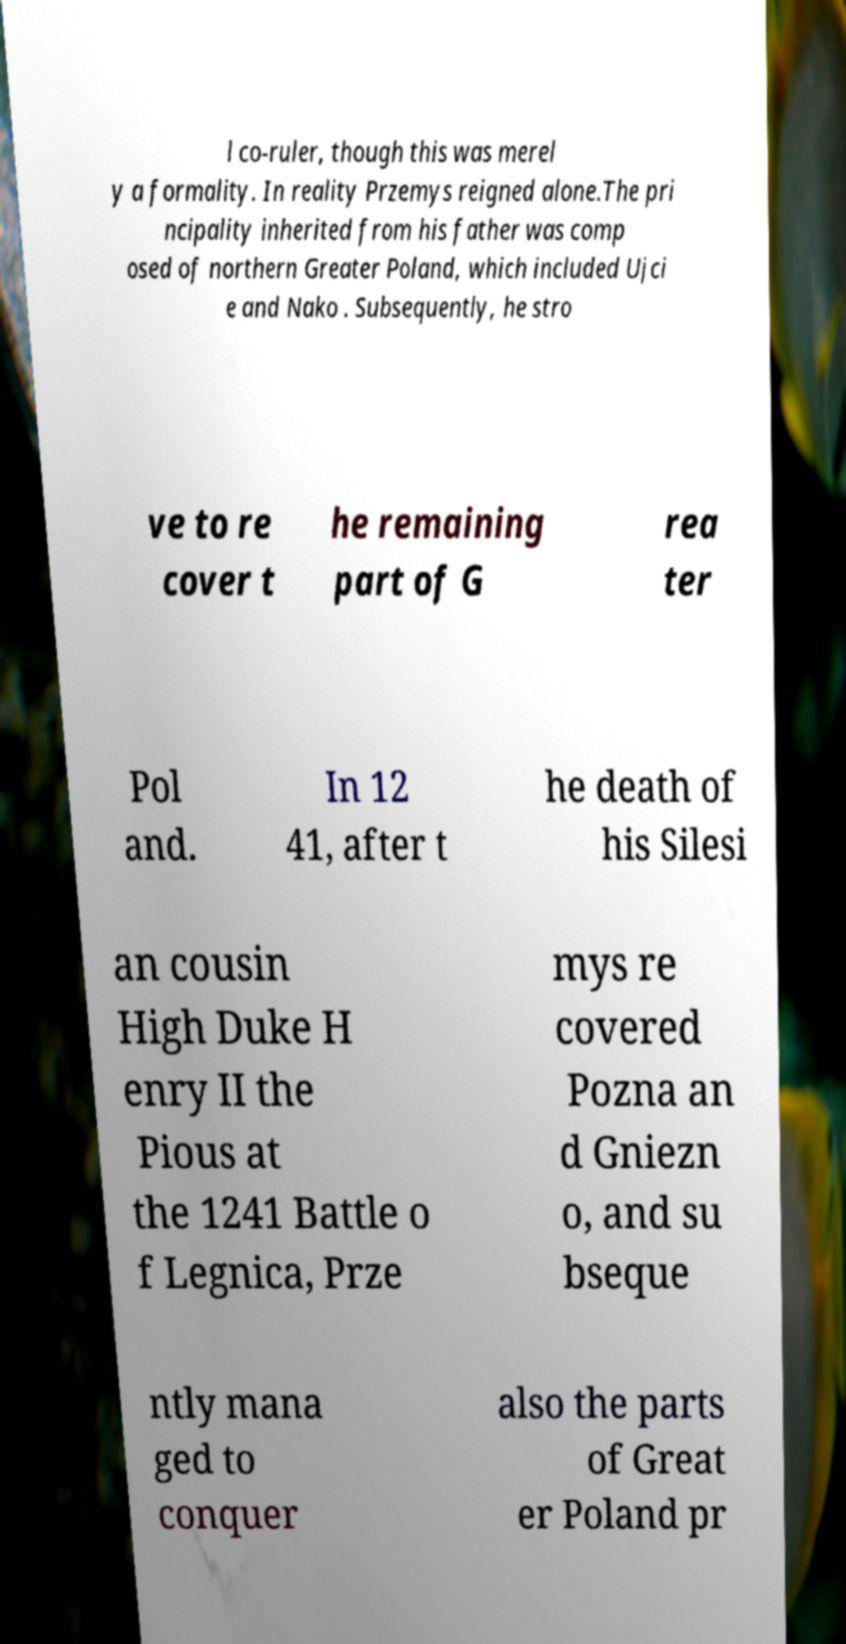Could you assist in decoding the text presented in this image and type it out clearly? l co-ruler, though this was merel y a formality. In reality Przemys reigned alone.The pri ncipality inherited from his father was comp osed of northern Greater Poland, which included Ujci e and Nako . Subsequently, he stro ve to re cover t he remaining part of G rea ter Pol and. In 12 41, after t he death of his Silesi an cousin High Duke H enry II the Pious at the 1241 Battle o f Legnica, Prze mys re covered Pozna an d Gniezn o, and su bseque ntly mana ged to conquer also the parts of Great er Poland pr 